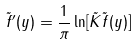<formula> <loc_0><loc_0><loc_500><loc_500>\tilde { f } ^ { \prime } ( y ) = \frac { 1 } { \pi } \ln [ \tilde { K } \tilde { f } ( y ) ]</formula> 